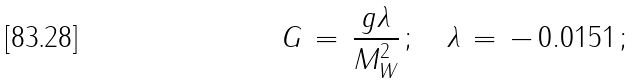Convert formula to latex. <formula><loc_0><loc_0><loc_500><loc_500>G \, = \, \frac { g \lambda } { M _ { W } ^ { 2 } } \, ; \quad \lambda \, = \, - \, 0 . 0 1 5 1 \, ;</formula> 